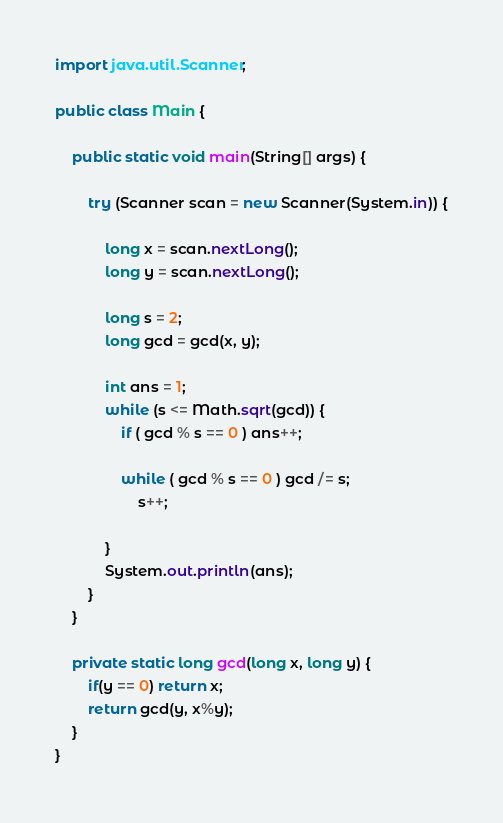Convert code to text. <code><loc_0><loc_0><loc_500><loc_500><_Java_>import java.util.Scanner;
 
public class Main {
 
	public static void main(String[] args) {
 
		try (Scanner scan = new Scanner(System.in)) {
 
			long x = scan.nextLong();
			long y = scan.nextLong();
 
			long s = 2;
			long gcd = gcd(x, y);
       
			int ans = 1;
			while (s <= Math.sqrt(gcd)) {
				if ( gcd % s == 0 ) ans++;
				
				while ( gcd % s == 0 ) gcd /= s;
					s++;
				
			}
			System.out.println(ans);
		}
	}
  
  	private static long gcd(long x, long y) {
  		if(y == 0) return x;
     	return gcd(y, x%y);     
    }
}</code> 